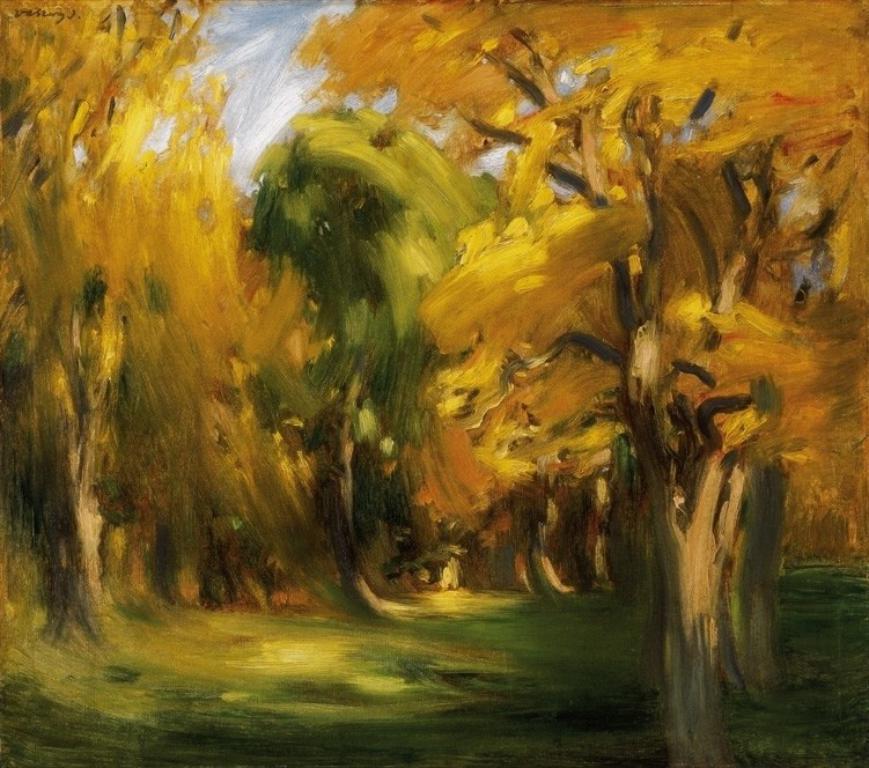Can you describe this image briefly? In this picture we can see painting of trees and sky. 